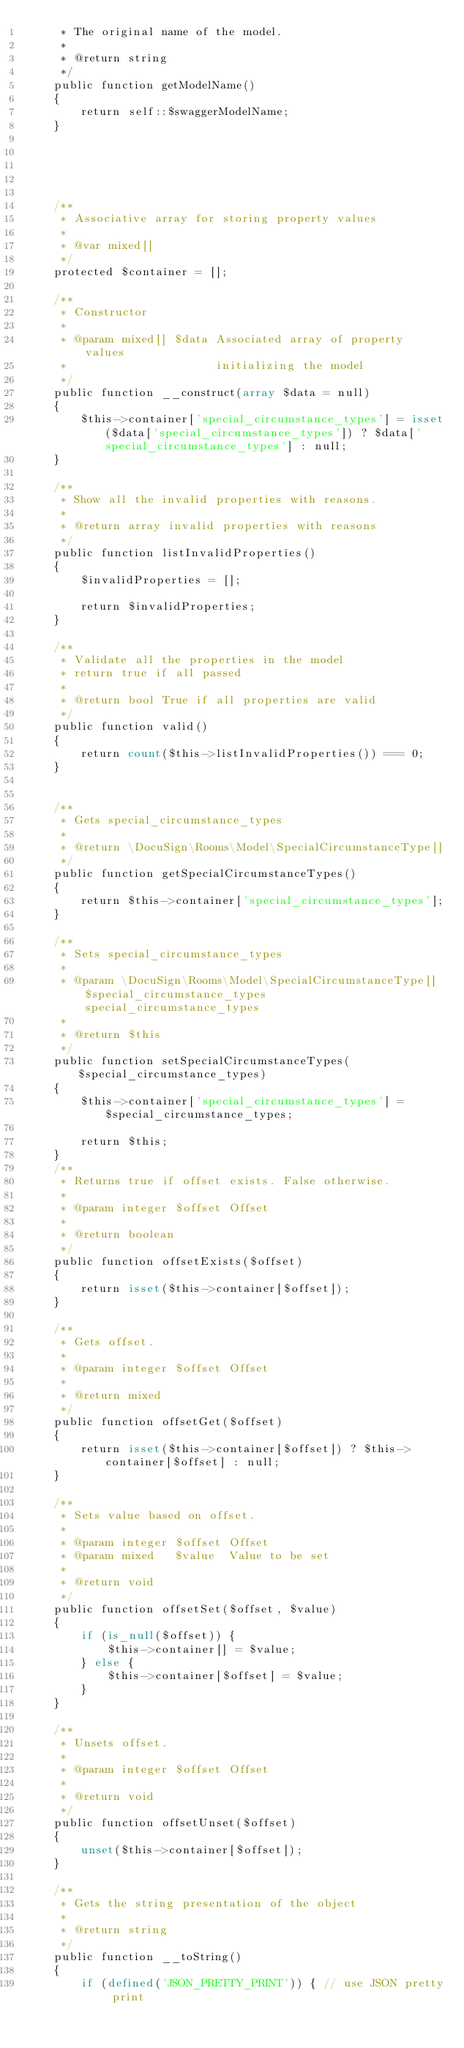<code> <loc_0><loc_0><loc_500><loc_500><_PHP_>     * The original name of the model.
     *
     * @return string
     */
    public function getModelName()
    {
        return self::$swaggerModelName;
    }

    

    

    /**
     * Associative array for storing property values
     *
     * @var mixed[]
     */
    protected $container = [];

    /**
     * Constructor
     *
     * @param mixed[] $data Associated array of property values
     *                      initializing the model
     */
    public function __construct(array $data = null)
    {
        $this->container['special_circumstance_types'] = isset($data['special_circumstance_types']) ? $data['special_circumstance_types'] : null;
    }

    /**
     * Show all the invalid properties with reasons.
     *
     * @return array invalid properties with reasons
     */
    public function listInvalidProperties()
    {
        $invalidProperties = [];

        return $invalidProperties;
    }

    /**
     * Validate all the properties in the model
     * return true if all passed
     *
     * @return bool True if all properties are valid
     */
    public function valid()
    {
        return count($this->listInvalidProperties()) === 0;
    }


    /**
     * Gets special_circumstance_types
     *
     * @return \DocuSign\Rooms\Model\SpecialCircumstanceType[]
     */
    public function getSpecialCircumstanceTypes()
    {
        return $this->container['special_circumstance_types'];
    }

    /**
     * Sets special_circumstance_types
     *
     * @param \DocuSign\Rooms\Model\SpecialCircumstanceType[] $special_circumstance_types special_circumstance_types
     *
     * @return $this
     */
    public function setSpecialCircumstanceTypes($special_circumstance_types)
    {
        $this->container['special_circumstance_types'] = $special_circumstance_types;

        return $this;
    }
    /**
     * Returns true if offset exists. False otherwise.
     *
     * @param integer $offset Offset
     *
     * @return boolean
     */
    public function offsetExists($offset)
    {
        return isset($this->container[$offset]);
    }

    /**
     * Gets offset.
     *
     * @param integer $offset Offset
     *
     * @return mixed
     */
    public function offsetGet($offset)
    {
        return isset($this->container[$offset]) ? $this->container[$offset] : null;
    }

    /**
     * Sets value based on offset.
     *
     * @param integer $offset Offset
     * @param mixed   $value  Value to be set
     *
     * @return void
     */
    public function offsetSet($offset, $value)
    {
        if (is_null($offset)) {
            $this->container[] = $value;
        } else {
            $this->container[$offset] = $value;
        }
    }

    /**
     * Unsets offset.
     *
     * @param integer $offset Offset
     *
     * @return void
     */
    public function offsetUnset($offset)
    {
        unset($this->container[$offset]);
    }

    /**
     * Gets the string presentation of the object
     *
     * @return string
     */
    public function __toString()
    {
        if (defined('JSON_PRETTY_PRINT')) { // use JSON pretty print</code> 